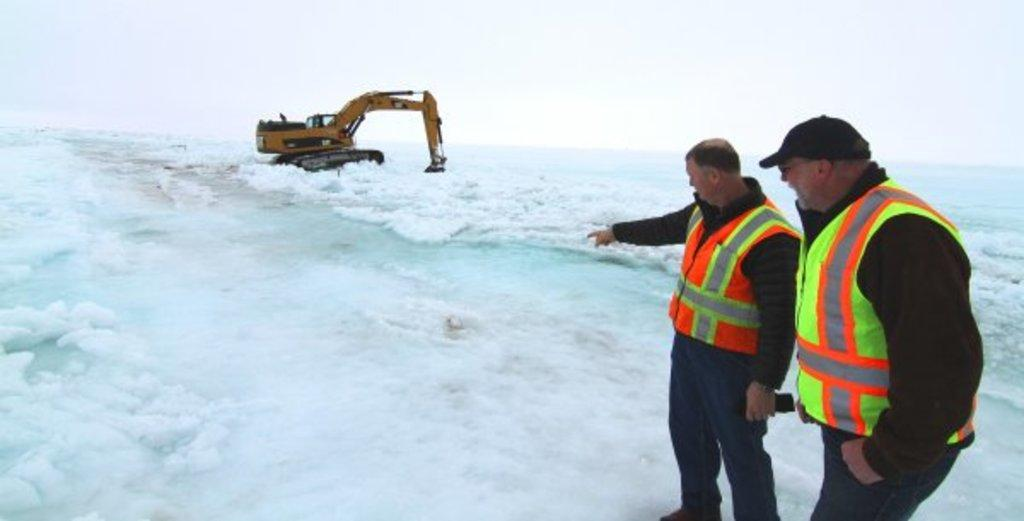How many people are in the image? There are two persons in the image. What can be seen in the image besides the people? There is a crane in the image. What is the condition of the ground in the image? The ground is covered with ice. What arithmetic problem can be solved using the numbers on the crane in the image? There are no numbers visible on the crane in the image, so it is not possible to solve an arithmetic problem based on the image. 